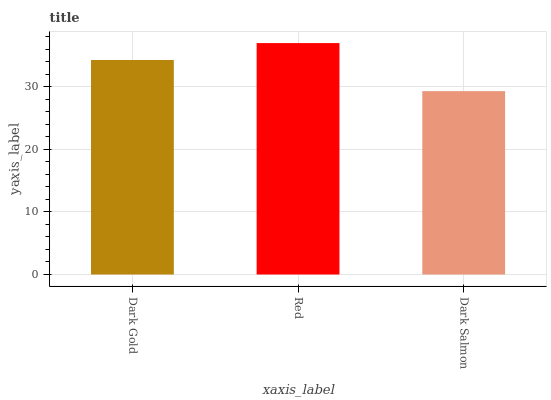Is Red the minimum?
Answer yes or no. No. Is Dark Salmon the maximum?
Answer yes or no. No. Is Red greater than Dark Salmon?
Answer yes or no. Yes. Is Dark Salmon less than Red?
Answer yes or no. Yes. Is Dark Salmon greater than Red?
Answer yes or no. No. Is Red less than Dark Salmon?
Answer yes or no. No. Is Dark Gold the high median?
Answer yes or no. Yes. Is Dark Gold the low median?
Answer yes or no. Yes. Is Red the high median?
Answer yes or no. No. Is Dark Salmon the low median?
Answer yes or no. No. 